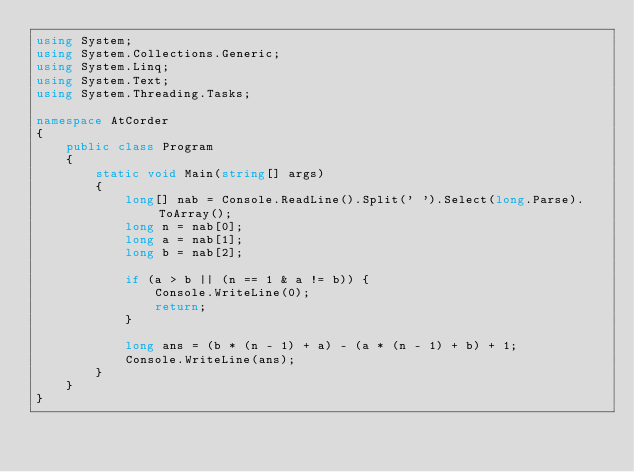Convert code to text. <code><loc_0><loc_0><loc_500><loc_500><_C#_>using System;
using System.Collections.Generic;
using System.Linq;
using System.Text;
using System.Threading.Tasks;

namespace AtCorder
{
	public class Program
	{
		static void Main(string[] args)
		{
			long[] nab = Console.ReadLine().Split(' ').Select(long.Parse).ToArray();
			long n = nab[0];
			long a = nab[1];
			long b = nab[2];

			if (a > b || (n == 1 & a != b)) {
				Console.WriteLine(0);
				return;
			}

			long ans = (b * (n - 1) + a) - (a * (n - 1) + b) + 1;
			Console.WriteLine(ans);
		}
	}
}
</code> 